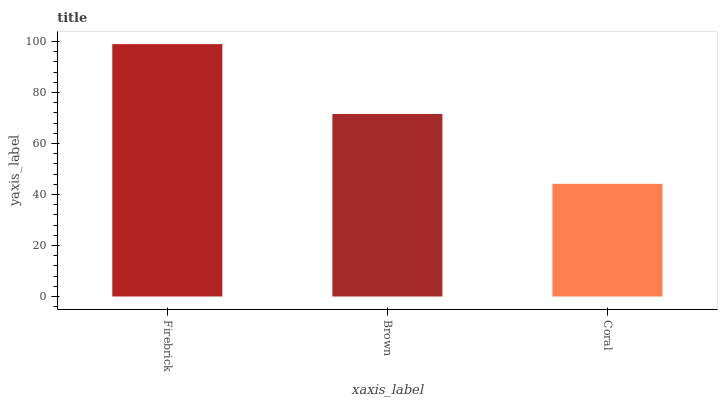Is Coral the minimum?
Answer yes or no. Yes. Is Firebrick the maximum?
Answer yes or no. Yes. Is Brown the minimum?
Answer yes or no. No. Is Brown the maximum?
Answer yes or no. No. Is Firebrick greater than Brown?
Answer yes or no. Yes. Is Brown less than Firebrick?
Answer yes or no. Yes. Is Brown greater than Firebrick?
Answer yes or no. No. Is Firebrick less than Brown?
Answer yes or no. No. Is Brown the high median?
Answer yes or no. Yes. Is Brown the low median?
Answer yes or no. Yes. Is Firebrick the high median?
Answer yes or no. No. Is Coral the low median?
Answer yes or no. No. 